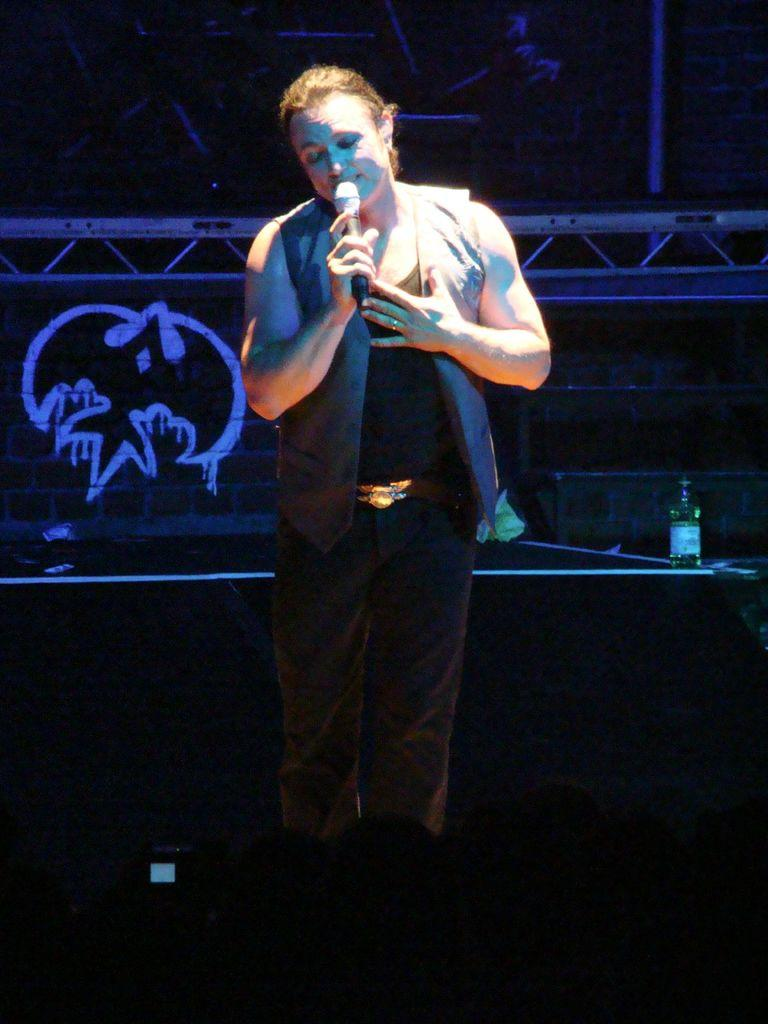What is the person in the image holding? The person is holding a microphone in the image. What can be seen in the background of the image? There is a wall, a bottle, and other objects visible in the background of the image. Can you describe the lighting in the image? The bottom of the image is dark. What electronic device is visible in the image? There is a mobile visible in the image. What type of trees can be seen in the image? There are no trees visible in the image. What thought is the person having while holding the microphone? The image does not provide any information about the person's thoughts, so it cannot be determined from the image. 